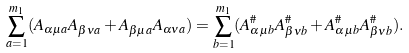Convert formula to latex. <formula><loc_0><loc_0><loc_500><loc_500>\sum _ { a = 1 } ^ { m _ { 1 } } ( A _ { \alpha \mu a } A _ { \beta \nu a } + A _ { \beta \mu a } A _ { \alpha \nu a } ) = \sum _ { b = 1 } ^ { m _ { 1 } } ( A ^ { \# } _ { \alpha \mu b } A ^ { \# } _ { \beta \nu b } + A ^ { \# } _ { \alpha \mu b } A ^ { \# } _ { \beta \nu b } ) .</formula> 